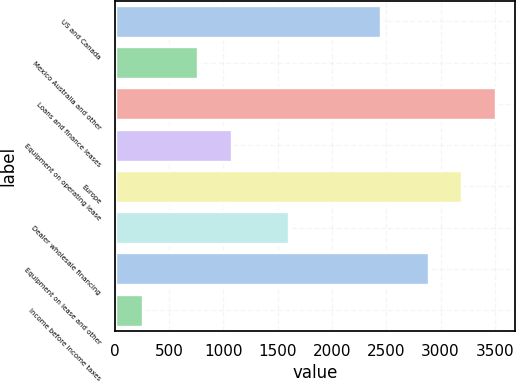Convert chart to OTSL. <chart><loc_0><loc_0><loc_500><loc_500><bar_chart><fcel>US and Canada<fcel>Mexico Australia and other<fcel>Loans and finance leases<fcel>Equipment on operating lease<fcel>Europe<fcel>Dealer wholesale financing<fcel>Equipment on lease and other<fcel>Income before income taxes<nl><fcel>2450.7<fcel>769.7<fcel>3507.6<fcel>1076.55<fcel>3200.75<fcel>1601.2<fcel>2893.9<fcel>261.7<nl></chart> 